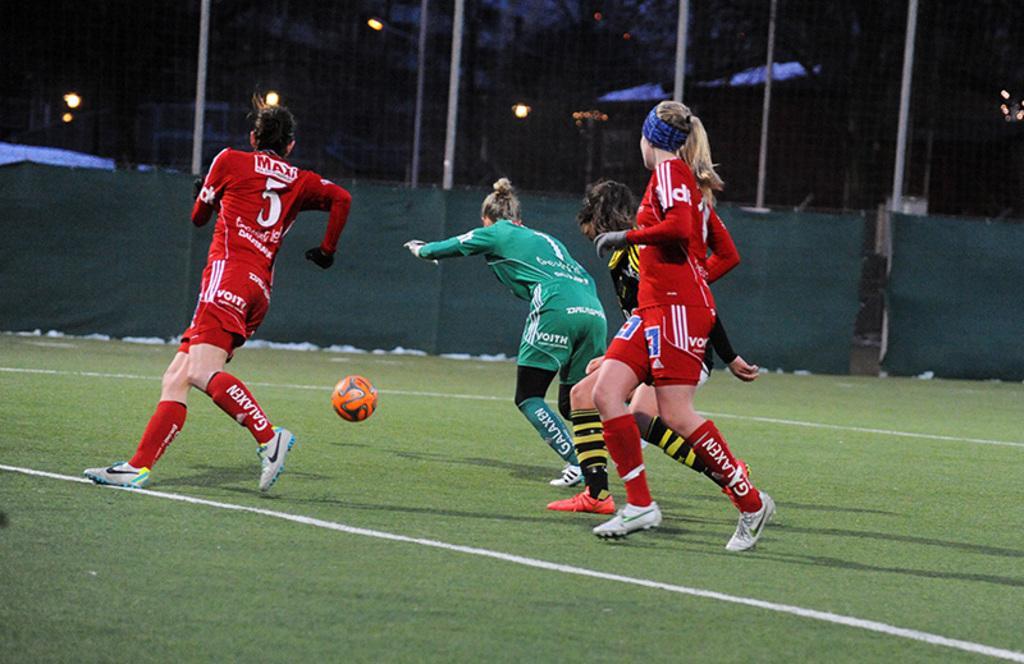Please provide a concise description of this image. In this picture there is a woman who is wearing green dress and white shoe. He is running to hit a football, beside her there is another woman who is wearing black dress and red shoe. On the left there is a woman who is wearing red dress and white shoe. He is also running to hit a football. In the bank i can see the building, poles, fencing and cloth. At the bottom i can see the grass. 